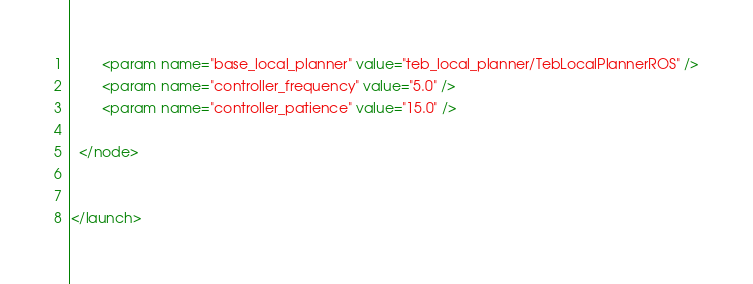<code> <loc_0><loc_0><loc_500><loc_500><_XML_>
		<param name="base_local_planner" value="teb_local_planner/TebLocalPlannerROS" />
		<param name="controller_frequency" value="5.0" />
		<param name="controller_patience" value="15.0" />

  </node>


</launch>


</code> 